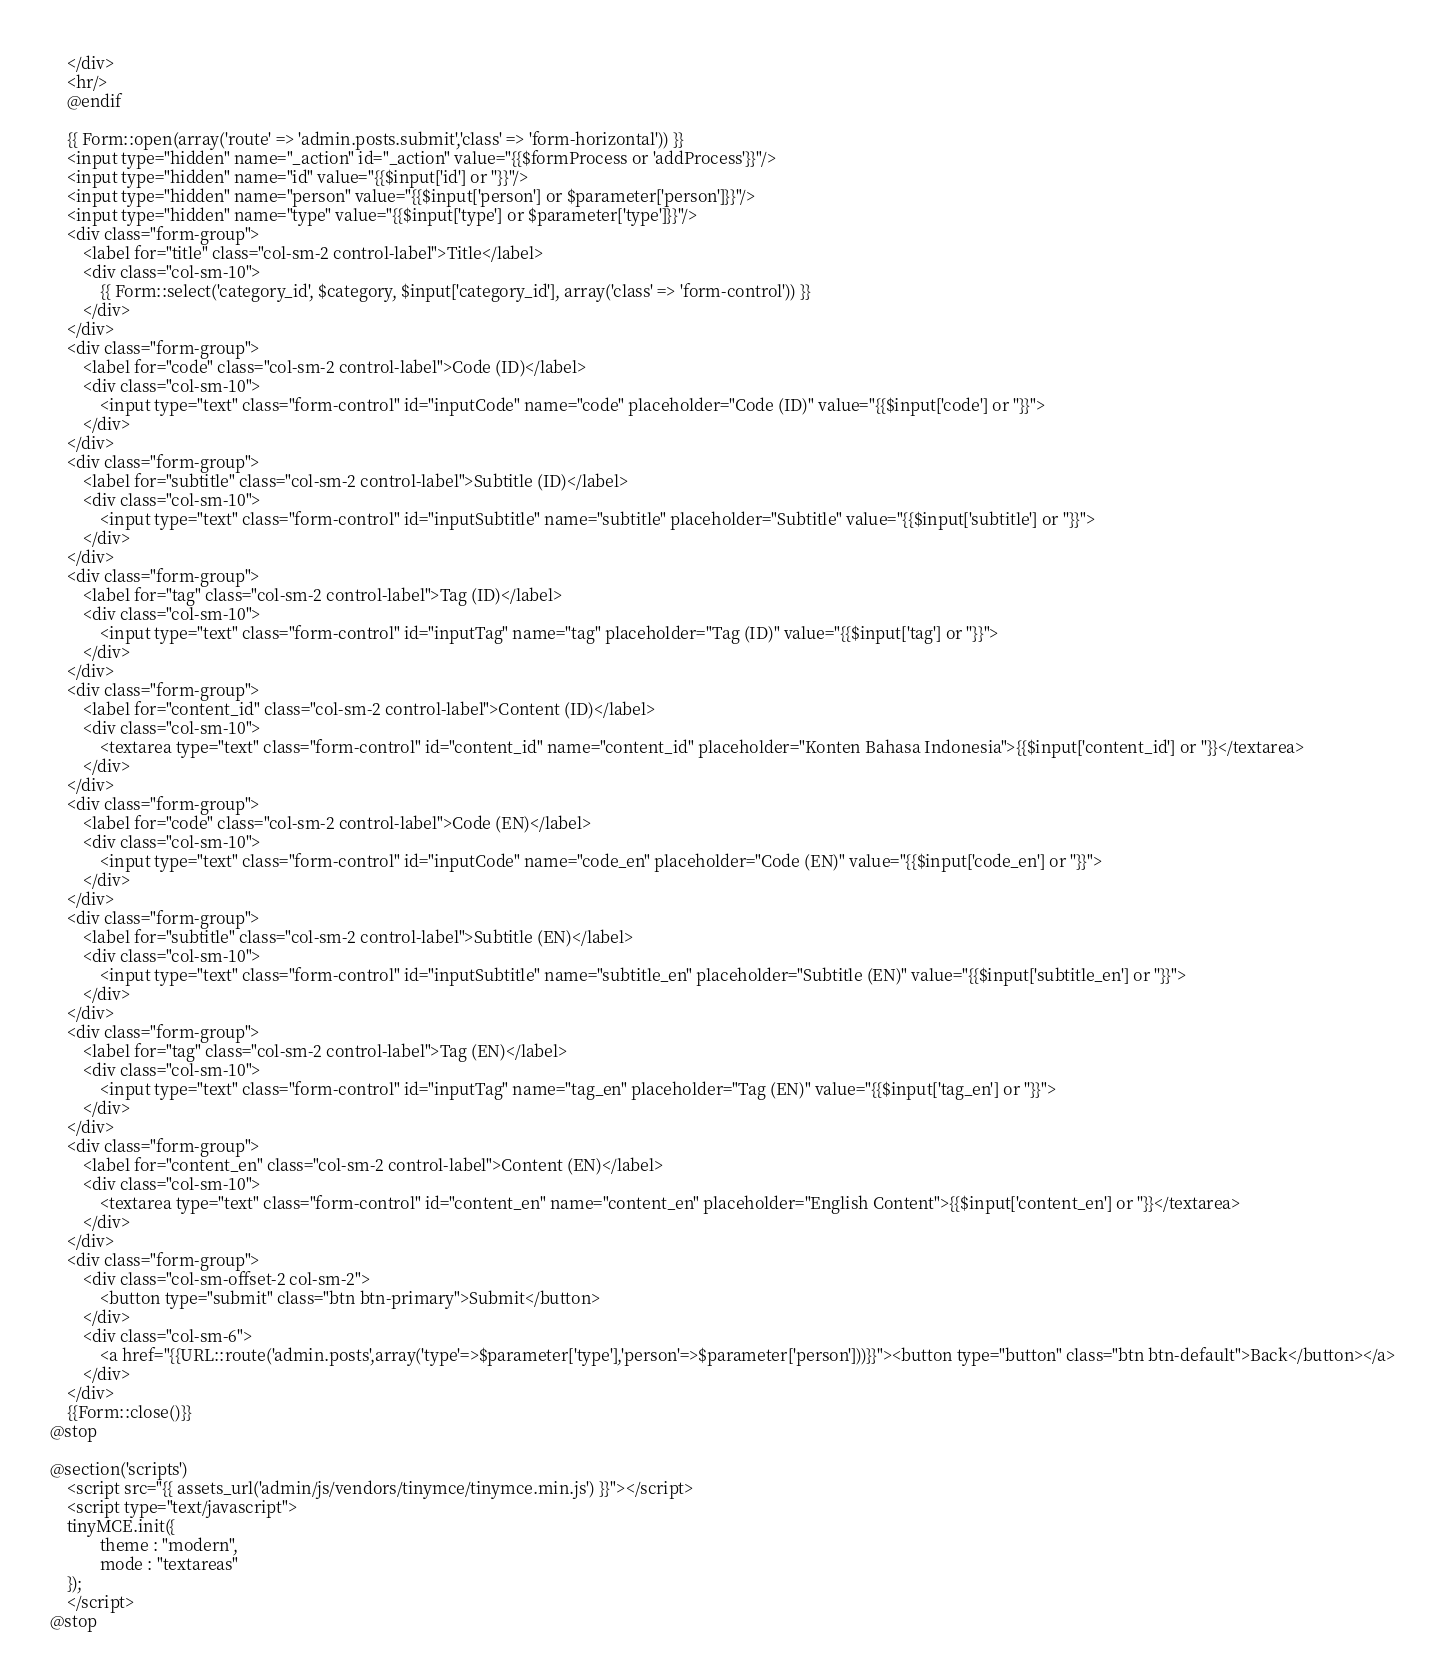Convert code to text. <code><loc_0><loc_0><loc_500><loc_500><_PHP_>	</div>
	<hr/>
	@endif
	
	{{ Form::open(array('route' => 'admin.posts.submit','class' => 'form-horizontal')) }}
	<input type="hidden" name="_action" id="_action" value="{{$formProcess or 'addProcess'}}"/>
	<input type="hidden" name="id" value="{{$input['id'] or ''}}"/>
	<input type="hidden" name="person" value="{{$input['person'] or $parameter['person']}}"/>
	<input type="hidden" name="type" value="{{$input['type'] or $parameter['type']}}"/>
	<div class="form-group">
		<label for="title" class="col-sm-2 control-label">Title</label>
		<div class="col-sm-10">
			{{ Form::select('category_id', $category, $input['category_id'], array('class' => 'form-control')) }}
		</div>
	</div>
	<div class="form-group">
		<label for="code" class="col-sm-2 control-label">Code (ID)</label>
		<div class="col-sm-10">
			<input type="text" class="form-control" id="inputCode" name="code" placeholder="Code (ID)" value="{{$input['code'] or ''}}">
		</div>
	</div>
	<div class="form-group">
		<label for="subtitle" class="col-sm-2 control-label">Subtitle (ID)</label>
		<div class="col-sm-10">
			<input type="text" class="form-control" id="inputSubtitle" name="subtitle" placeholder="Subtitle" value="{{$input['subtitle'] or ''}}">
		</div>
	</div>
	<div class="form-group">
		<label for="tag" class="col-sm-2 control-label">Tag (ID)</label>
		<div class="col-sm-10">
			<input type="text" class="form-control" id="inputTag" name="tag" placeholder="Tag (ID)" value="{{$input['tag'] or ''}}">
		</div>
	</div>
	<div class="form-group">
		<label for="content_id" class="col-sm-2 control-label">Content (ID)</label>
		<div class="col-sm-10">
			<textarea type="text" class="form-control" id="content_id" name="content_id" placeholder="Konten Bahasa Indonesia">{{$input['content_id'] or ''}}</textarea>
		</div>
	</div>
	<div class="form-group">
		<label for="code" class="col-sm-2 control-label">Code (EN)</label>
		<div class="col-sm-10">
			<input type="text" class="form-control" id="inputCode" name="code_en" placeholder="Code (EN)" value="{{$input['code_en'] or ''}}">
		</div>
	</div>
	<div class="form-group">
		<label for="subtitle" class="col-sm-2 control-label">Subtitle (EN)</label>
		<div class="col-sm-10">
			<input type="text" class="form-control" id="inputSubtitle" name="subtitle_en" placeholder="Subtitle (EN)" value="{{$input['subtitle_en'] or ''}}">
		</div>
	</div>
	<div class="form-group">
		<label for="tag" class="col-sm-2 control-label">Tag (EN)</label>
		<div class="col-sm-10">
			<input type="text" class="form-control" id="inputTag" name="tag_en" placeholder="Tag (EN)" value="{{$input['tag_en'] or ''}}">
		</div>
	</div>
	<div class="form-group">
		<label for="content_en" class="col-sm-2 control-label">Content (EN)</label>
		<div class="col-sm-10">
			<textarea type="text" class="form-control" id="content_en" name="content_en" placeholder="English Content">{{$input['content_en'] or ''}}</textarea>
		</div>
	</div>
	<div class="form-group">
		<div class="col-sm-offset-2 col-sm-2">
			<button type="submit" class="btn btn-primary">Submit</button>
		</div>
		<div class="col-sm-6">
			<a href="{{URL::route('admin.posts',array('type'=>$parameter['type'],'person'=>$parameter['person']))}}"><button type="button" class="btn btn-default">Back</button></a>
		</div>
	</div>
	{{Form::close()}}
@stop

@section('scripts')
    <script src="{{ assets_url('admin/js/vendors/tinymce/tinymce.min.js') }}"></script>
	<script type="text/javascript">
	tinyMCE.init({
			theme : "modern",
			mode : "textareas"
	});
	</script>
@stop</code> 